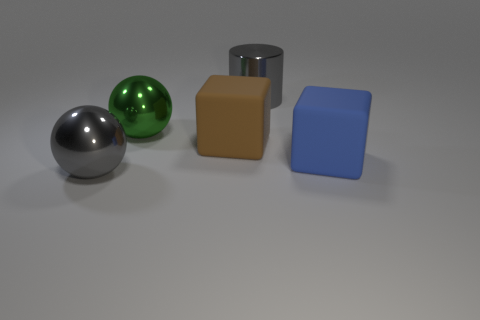There is a large rubber thing that is in front of the brown thing; what number of large shiny objects are in front of it?
Make the answer very short. 1. What shape is the gray metallic object left of the big gray thing that is right of the sphere to the left of the big green metal ball?
Provide a short and direct response. Sphere. There is a metal sphere that is the same color as the large metallic cylinder; what size is it?
Your response must be concise. Large. How many objects are big yellow rubber cubes or big blocks?
Offer a terse response. 2. What color is the cylinder that is the same size as the blue cube?
Give a very brief answer. Gray. There is a green metal object; does it have the same shape as the big gray object right of the big brown block?
Your answer should be very brief. No. What number of objects are either gray metal objects that are right of the large gray metal ball or large gray metal objects to the left of the large brown cube?
Your response must be concise. 2. The shiny object that is the same color as the big shiny cylinder is what shape?
Your response must be concise. Sphere. There is a big gray metallic thing behind the big gray shiny ball; what is its shape?
Offer a terse response. Cylinder. There is a large metallic object in front of the big green thing; does it have the same shape as the blue object?
Keep it short and to the point. No. 